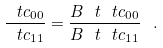Convert formula to latex. <formula><loc_0><loc_0><loc_500><loc_500>\frac { \ t c _ { 0 0 } } { \ t c _ { 1 1 } } = \frac { B _ { \ } t \ t c _ { 0 0 } } { B _ { \ } t \ t c _ { 1 1 } } \ .</formula> 